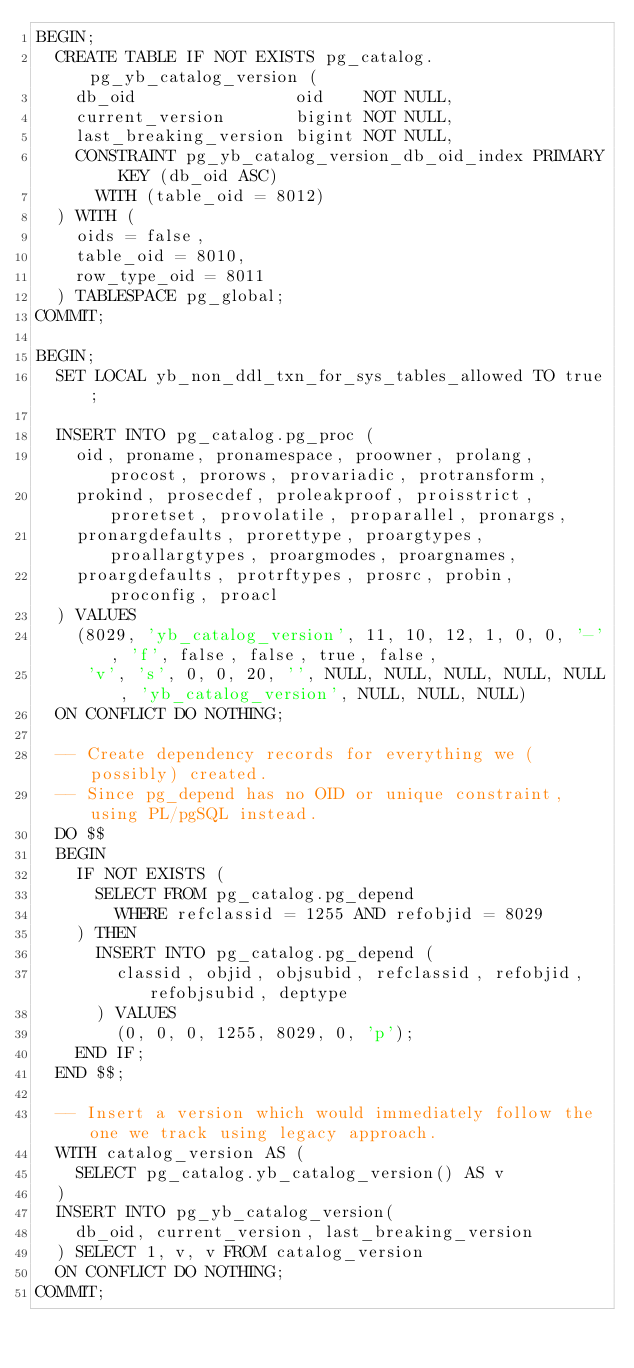<code> <loc_0><loc_0><loc_500><loc_500><_SQL_>BEGIN;
  CREATE TABLE IF NOT EXISTS pg_catalog.pg_yb_catalog_version (
    db_oid                oid    NOT NULL,
    current_version       bigint NOT NULL,
    last_breaking_version bigint NOT NULL,
    CONSTRAINT pg_yb_catalog_version_db_oid_index PRIMARY KEY (db_oid ASC)
      WITH (table_oid = 8012)
  ) WITH (
    oids = false,
    table_oid = 8010,
    row_type_oid = 8011
  ) TABLESPACE pg_global;
COMMIT;

BEGIN;
  SET LOCAL yb_non_ddl_txn_for_sys_tables_allowed TO true;

  INSERT INTO pg_catalog.pg_proc (
    oid, proname, pronamespace, proowner, prolang, procost, prorows, provariadic, protransform,
    prokind, prosecdef, proleakproof, proisstrict, proretset, provolatile, proparallel, pronargs,
    pronargdefaults, prorettype, proargtypes, proallargtypes, proargmodes, proargnames,
    proargdefaults, protrftypes, prosrc, probin, proconfig, proacl
  ) VALUES
    (8029, 'yb_catalog_version', 11, 10, 12, 1, 0, 0, '-', 'f', false, false, true, false,
     'v', 's', 0, 0, 20, '', NULL, NULL, NULL, NULL, NULL, 'yb_catalog_version', NULL, NULL, NULL)
  ON CONFLICT DO NOTHING;

  -- Create dependency records for everything we (possibly) created.
  -- Since pg_depend has no OID or unique constraint, using PL/pgSQL instead.
  DO $$
  BEGIN
    IF NOT EXISTS (
      SELECT FROM pg_catalog.pg_depend
        WHERE refclassid = 1255 AND refobjid = 8029
    ) THEN
      INSERT INTO pg_catalog.pg_depend (
        classid, objid, objsubid, refclassid, refobjid, refobjsubid, deptype
      ) VALUES
        (0, 0, 0, 1255, 8029, 0, 'p');
    END IF;
  END $$;

  -- Insert a version which would immediately follow the one we track using legacy approach.
  WITH catalog_version AS (
    SELECT pg_catalog.yb_catalog_version() AS v
  )
  INSERT INTO pg_yb_catalog_version(
    db_oid, current_version, last_breaking_version
  ) SELECT 1, v, v FROM catalog_version
  ON CONFLICT DO NOTHING;
COMMIT;
</code> 